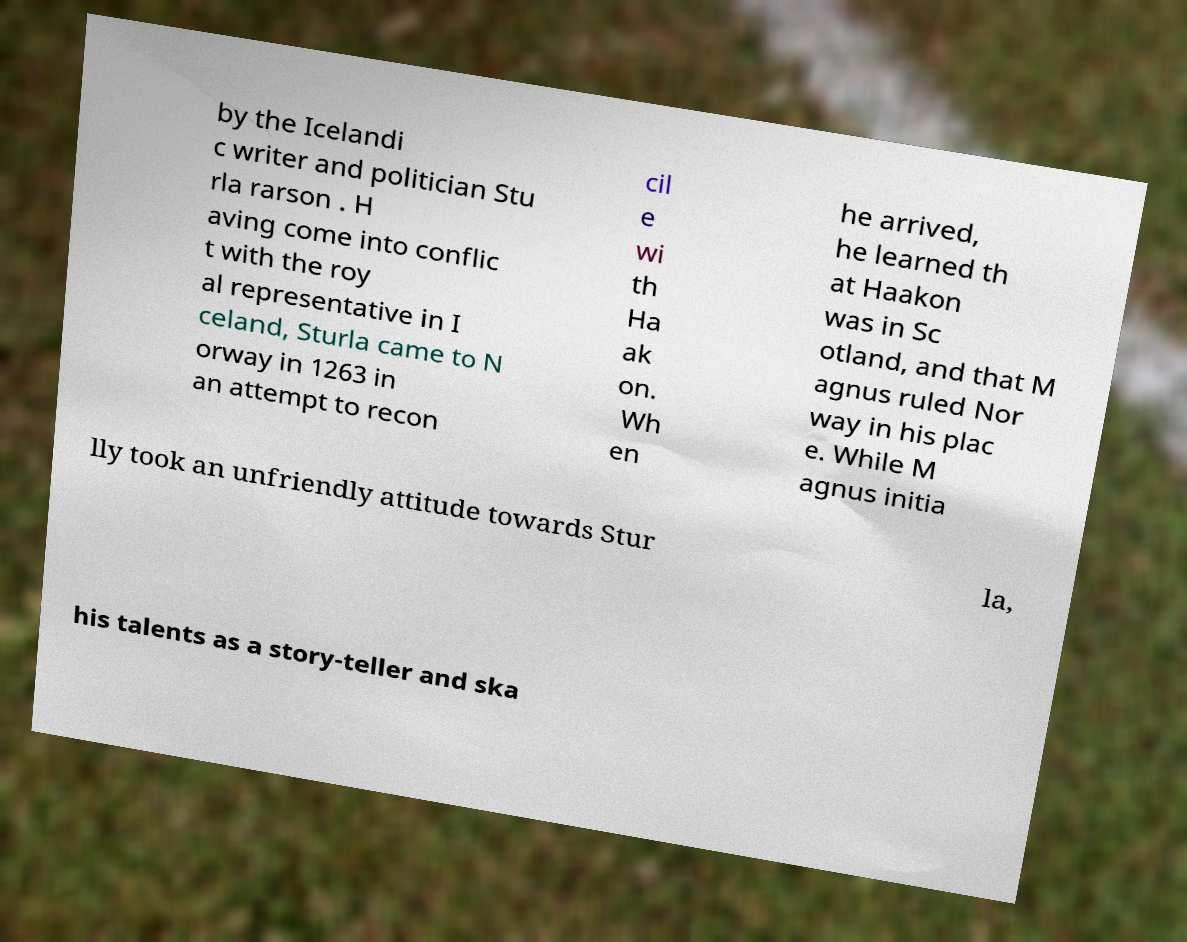Could you extract and type out the text from this image? by the Icelandi c writer and politician Stu rla rarson . H aving come into conflic t with the roy al representative in I celand, Sturla came to N orway in 1263 in an attempt to recon cil e wi th Ha ak on. Wh en he arrived, he learned th at Haakon was in Sc otland, and that M agnus ruled Nor way in his plac e. While M agnus initia lly took an unfriendly attitude towards Stur la, his talents as a story-teller and ska 